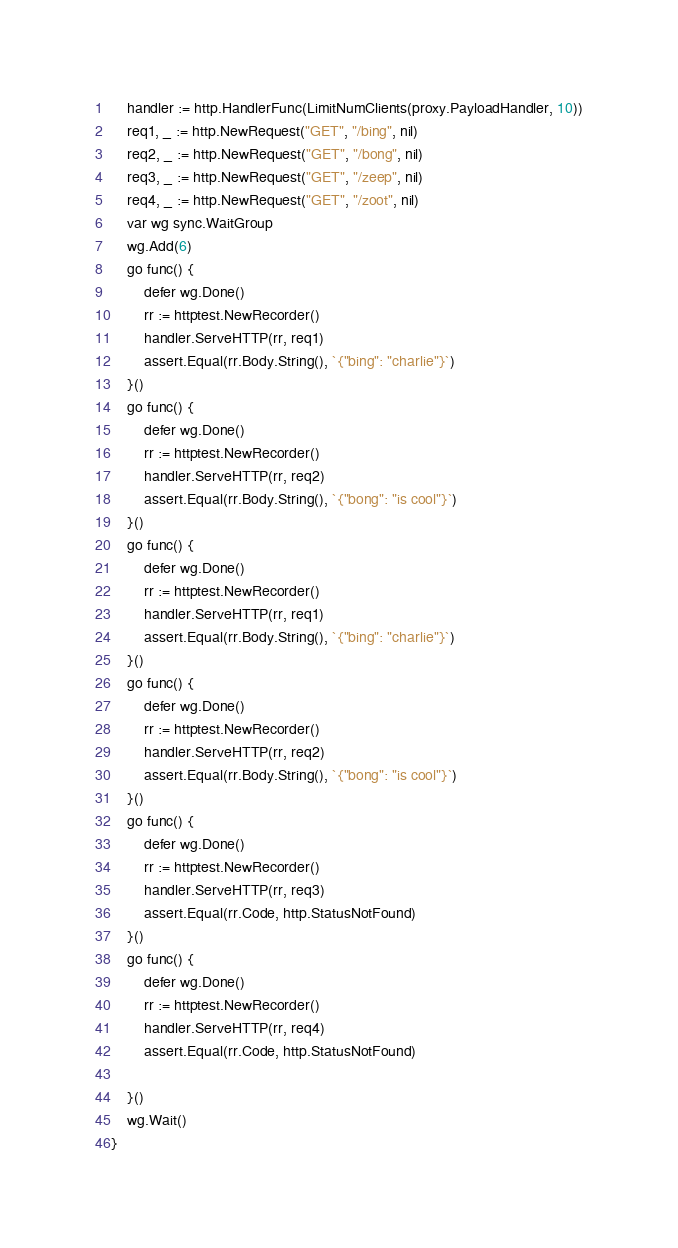<code> <loc_0><loc_0><loc_500><loc_500><_Go_>	handler := http.HandlerFunc(LimitNumClients(proxy.PayloadHandler, 10))
	req1, _ := http.NewRequest("GET", "/bing", nil)
	req2, _ := http.NewRequest("GET", "/bong", nil)
	req3, _ := http.NewRequest("GET", "/zeep", nil)
	req4, _ := http.NewRequest("GET", "/zoot", nil)
	var wg sync.WaitGroup
	wg.Add(6)
	go func() {
		defer wg.Done()
		rr := httptest.NewRecorder()
		handler.ServeHTTP(rr, req1)
		assert.Equal(rr.Body.String(), `{"bing": "charlie"}`)
	}()
	go func() {
		defer wg.Done()
		rr := httptest.NewRecorder()
		handler.ServeHTTP(rr, req2)
		assert.Equal(rr.Body.String(), `{"bong": "is cool"}`)
	}()
	go func() {
		defer wg.Done()
		rr := httptest.NewRecorder()
		handler.ServeHTTP(rr, req1)
		assert.Equal(rr.Body.String(), `{"bing": "charlie"}`)
	}()
	go func() {
		defer wg.Done()
		rr := httptest.NewRecorder()
		handler.ServeHTTP(rr, req2)
		assert.Equal(rr.Body.String(), `{"bong": "is cool"}`)
	}()
	go func() {
		defer wg.Done()
		rr := httptest.NewRecorder()
		handler.ServeHTTP(rr, req3)
		assert.Equal(rr.Code, http.StatusNotFound)
	}()
	go func() {
		defer wg.Done()
		rr := httptest.NewRecorder()
		handler.ServeHTTP(rr, req4)
		assert.Equal(rr.Code, http.StatusNotFound)

	}()
	wg.Wait()
}
</code> 